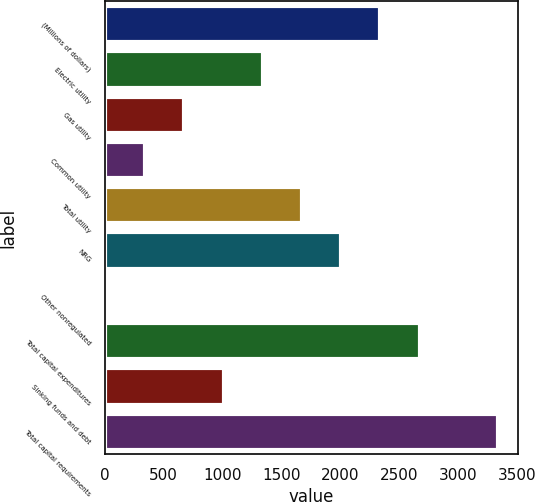Convert chart. <chart><loc_0><loc_0><loc_500><loc_500><bar_chart><fcel>(Millions of dollars)<fcel>Electric utility<fcel>Gas utility<fcel>Common utility<fcel>Total utility<fcel>NRG<fcel>Other nonregulated<fcel>Total capital expenditures<fcel>Sinking funds and debt<fcel>Total capital requirements<nl><fcel>2340.2<fcel>1342.4<fcel>677.2<fcel>344.6<fcel>1675<fcel>2007.6<fcel>12<fcel>2675<fcel>1009.8<fcel>3338<nl></chart> 